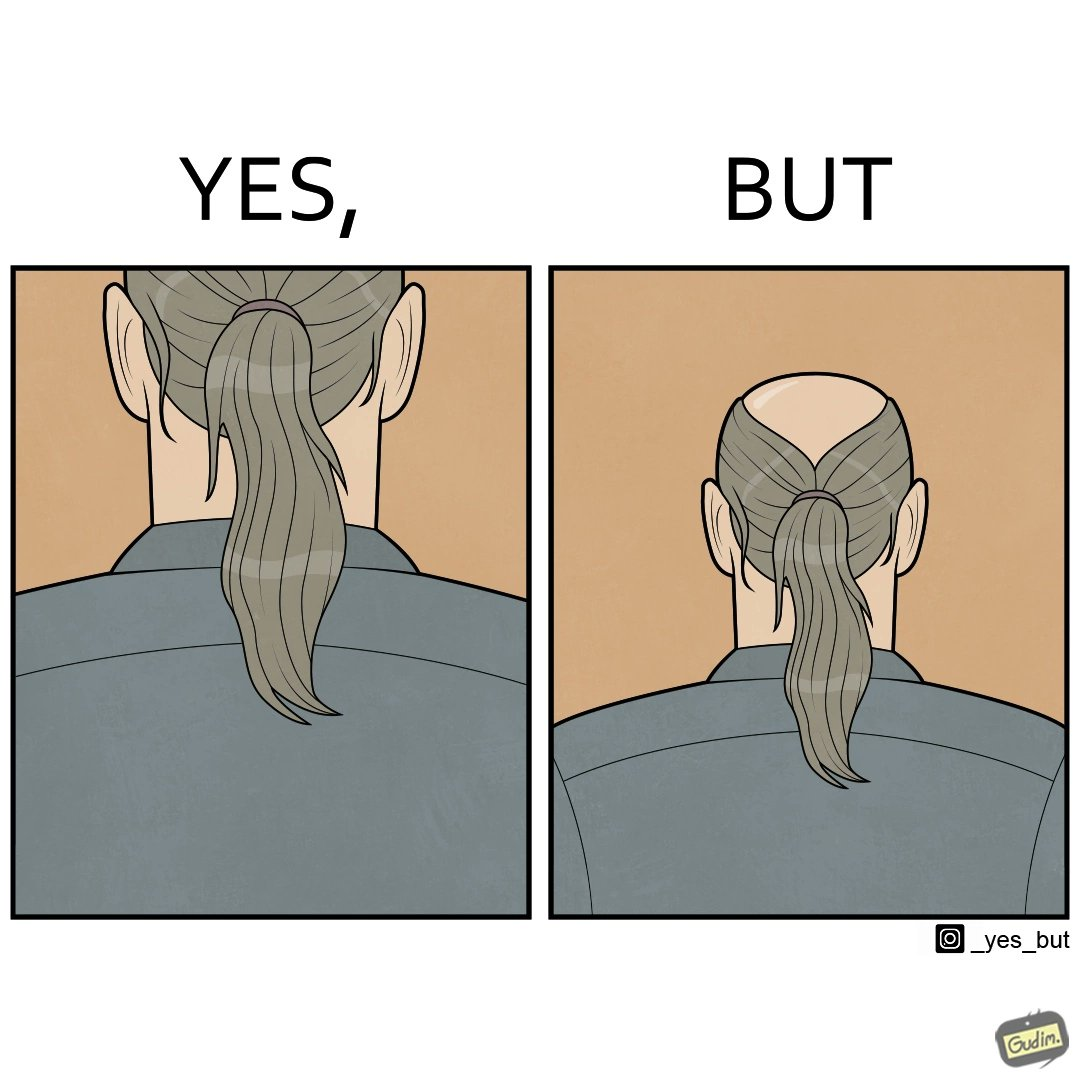Does this image contain satire or humor? Yes, this image is satirical. 